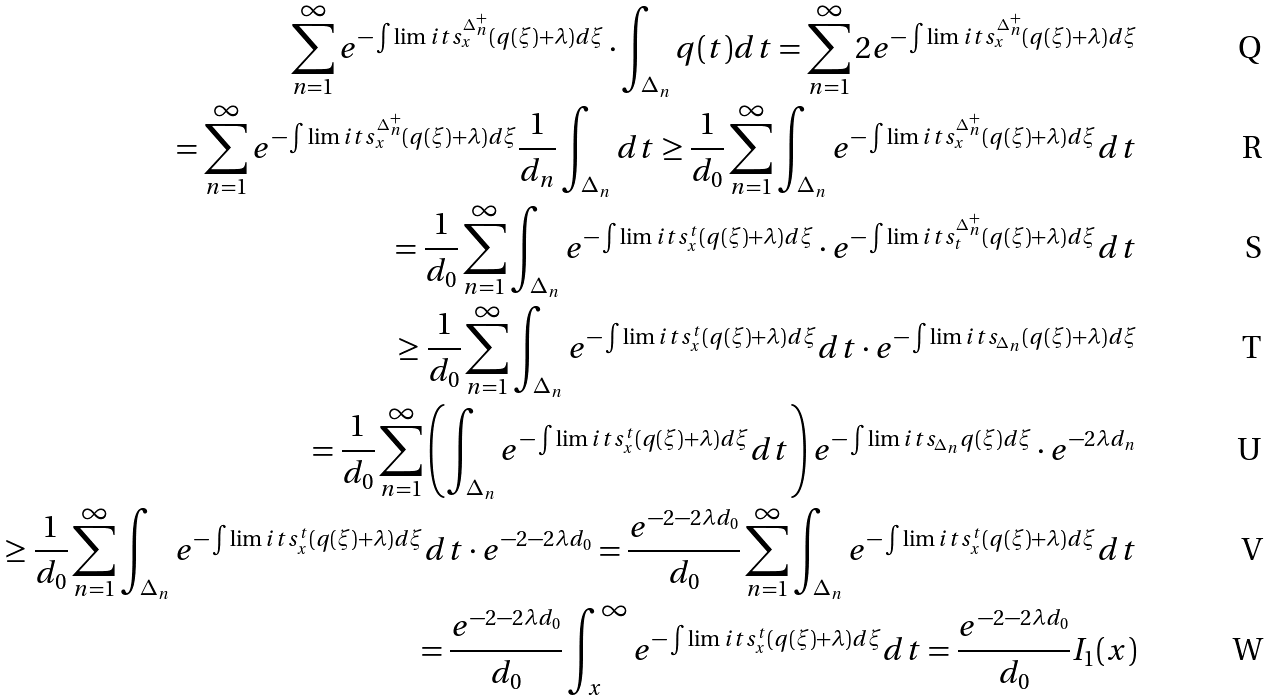<formula> <loc_0><loc_0><loc_500><loc_500>\sum _ { n = 1 } ^ { \infty } e ^ { - \int \lim i t s _ { x } ^ { \Delta _ { n } ^ { + } } ( q ( \xi ) + \lambda ) d \xi } \cdot \int _ { \Delta _ { n } } q ( t ) d t = \sum _ { n = 1 } ^ { \infty } 2 e ^ { - \int \lim i t s _ { x } ^ { \Delta _ { n } ^ { + } } ( q ( \xi ) + \lambda ) d \xi } \\ = \sum _ { n = 1 } ^ { \infty } e ^ { - \int \lim i t s _ { x } ^ { \Delta _ { n } ^ { + } } ( q ( \xi ) + \lambda ) d \xi } \frac { 1 } { d _ { n } } \int _ { \Delta _ { n } } d t \geq \frac { 1 } { d _ { 0 } } \sum _ { n = 1 } ^ { \infty } \int _ { \Delta _ { n } } e ^ { - \int \lim i t s _ { x } ^ { \Delta _ { n } ^ { + } } ( q ( \xi ) + \lambda ) d \xi } d t \\ = \frac { 1 } { d _ { 0 } } \sum _ { n = 1 } ^ { \infty } \int _ { \Delta _ { n } } e ^ { - \int \lim i t s _ { x } ^ { t } ( q ( \xi ) + \lambda ) d \xi } \cdot e ^ { - \int \lim i t s _ { t } ^ { \Delta _ { n } ^ { + } } ( q ( \xi ) + \lambda ) d \xi } d t \\ \geq \frac { 1 } { d _ { 0 } } \sum _ { n = 1 } ^ { \infty } \int _ { \Delta _ { n } } e ^ { - \int \lim i t s _ { x } ^ { t } ( q ( \xi ) + \lambda ) d \xi } d t \cdot e ^ { - \int \lim i t s _ { \Delta _ { n } } ( q ( \xi ) + \lambda ) d \xi } \\ = \frac { 1 } { d _ { 0 } } \sum _ { n = 1 } ^ { \infty } \left ( \int _ { \Delta _ { n } } e ^ { - \int \lim i t s _ { x } ^ { t } ( q ( \xi ) + \lambda ) d \xi } d t \right ) e ^ { - \int \lim i t s _ { \Delta _ { n } } q ( \xi ) d \xi } \cdot e ^ { - 2 \lambda d _ { n } } \\ \geq \frac { 1 } { d _ { 0 } } \sum _ { n = 1 } ^ { \infty } \int _ { \Delta _ { n } } e ^ { - \int \lim i t s _ { x } ^ { t } ( q ( \xi ) + \lambda ) d \xi } d t \cdot e ^ { - 2 - 2 \lambda d _ { 0 } } = \frac { e ^ { - 2 - 2 \lambda d _ { 0 } } } { d _ { 0 } } \sum _ { n = 1 } ^ { \infty } \int _ { \Delta _ { n } } e ^ { - \int \lim i t s _ { x } ^ { t } ( q ( \xi ) + \lambda ) d \xi } d t \\ = \frac { e ^ { - 2 - 2 \lambda d _ { 0 } } } { d _ { 0 } } \int _ { x } ^ { \infty } e ^ { - \int \lim i t s _ { x } ^ { t } ( q ( \xi ) + \lambda ) d \xi } d t = \frac { e ^ { - 2 - 2 \lambda d _ { 0 } } } { d _ { 0 } } I _ { 1 } ( x )</formula> 